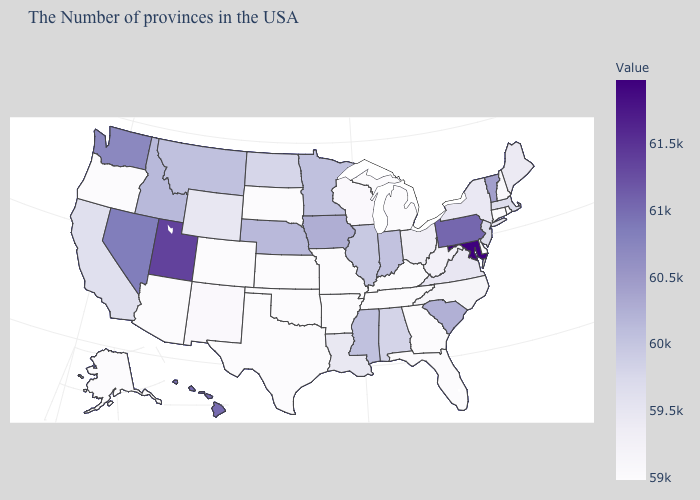Which states have the lowest value in the West?
Give a very brief answer. Colorado, Arizona, Oregon, Alaska. Does Pennsylvania have the highest value in the Northeast?
Short answer required. Yes. Which states have the highest value in the USA?
Keep it brief. Maryland. 